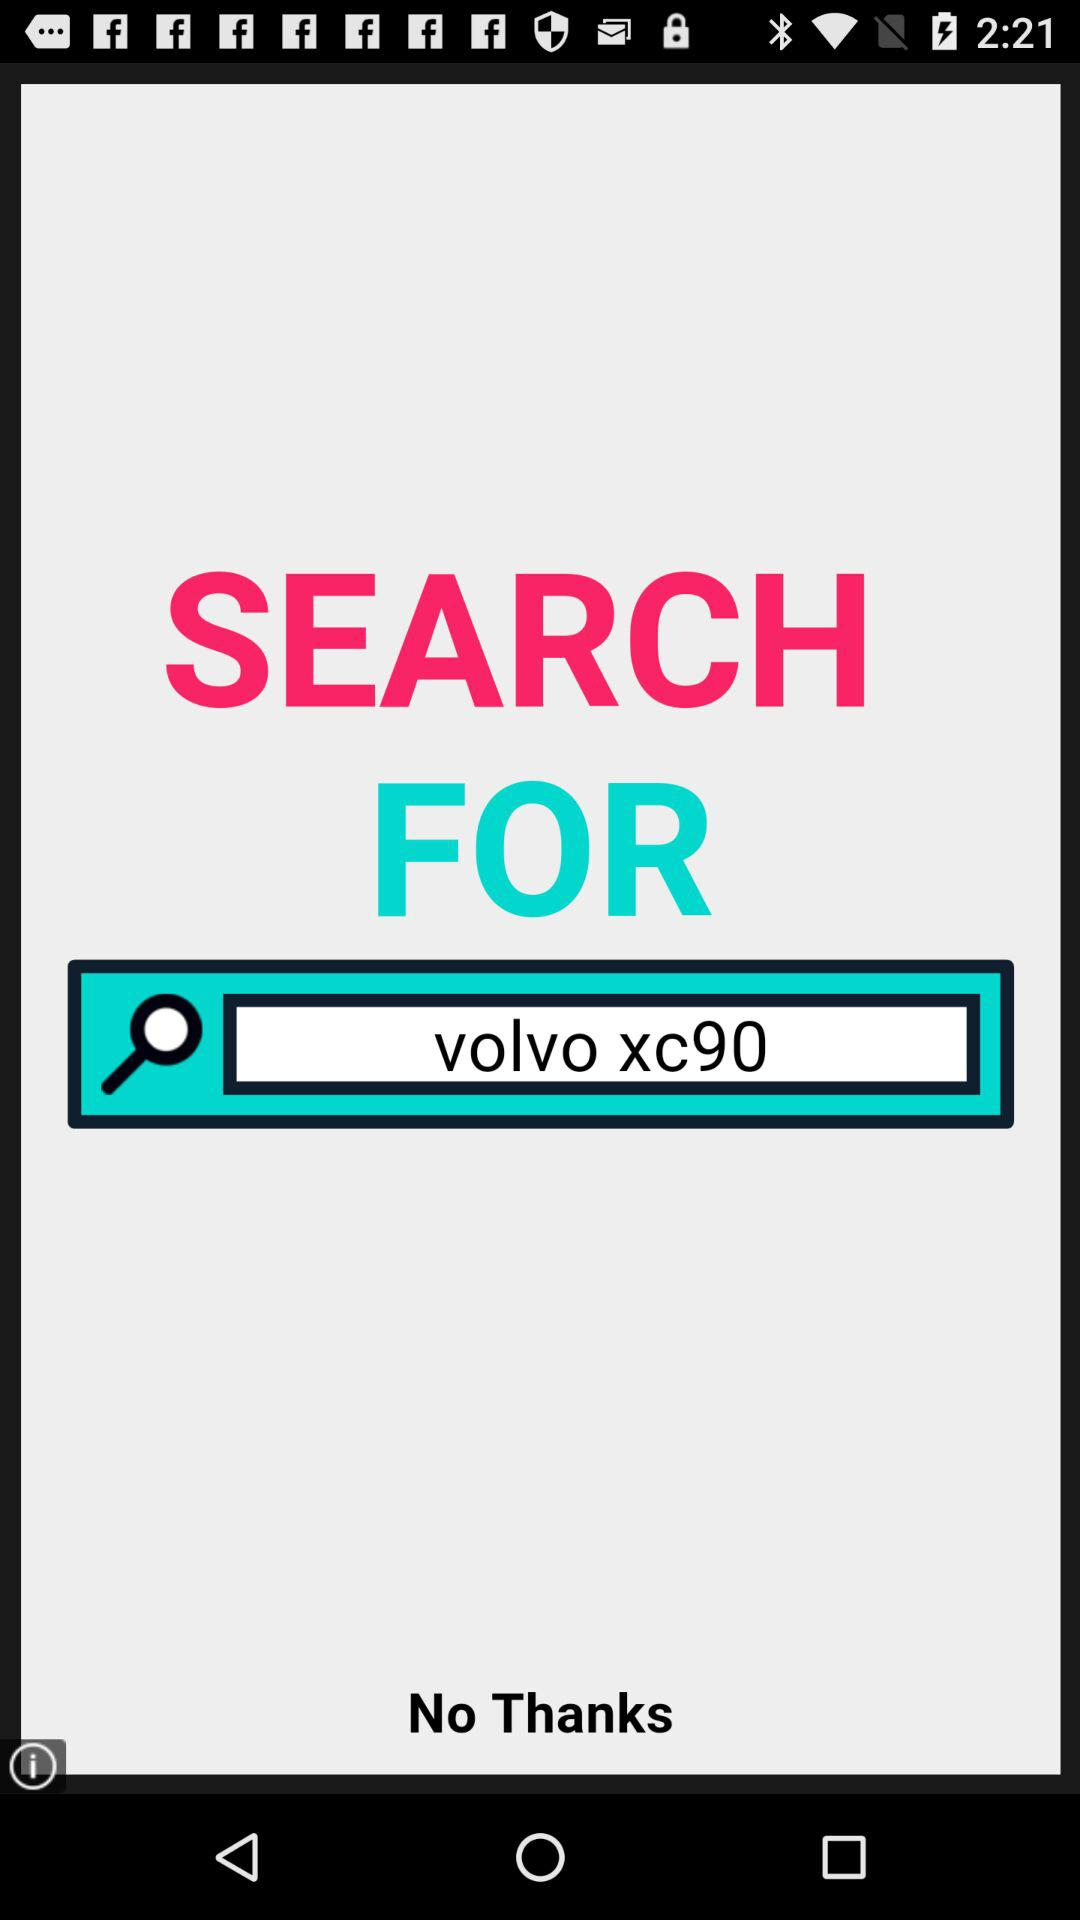What is the value input in the search bar? The value input is "volvo xc90". 